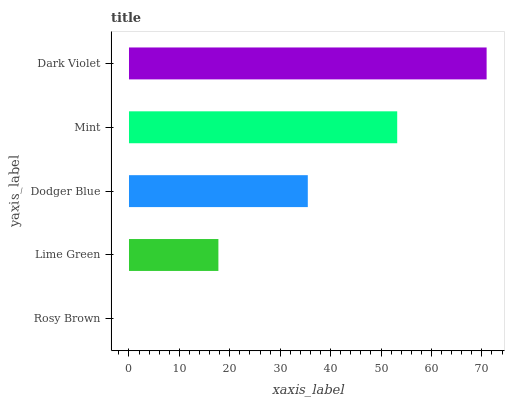Is Rosy Brown the minimum?
Answer yes or no. Yes. Is Dark Violet the maximum?
Answer yes or no. Yes. Is Lime Green the minimum?
Answer yes or no. No. Is Lime Green the maximum?
Answer yes or no. No. Is Lime Green greater than Rosy Brown?
Answer yes or no. Yes. Is Rosy Brown less than Lime Green?
Answer yes or no. Yes. Is Rosy Brown greater than Lime Green?
Answer yes or no. No. Is Lime Green less than Rosy Brown?
Answer yes or no. No. Is Dodger Blue the high median?
Answer yes or no. Yes. Is Dodger Blue the low median?
Answer yes or no. Yes. Is Mint the high median?
Answer yes or no. No. Is Dark Violet the low median?
Answer yes or no. No. 